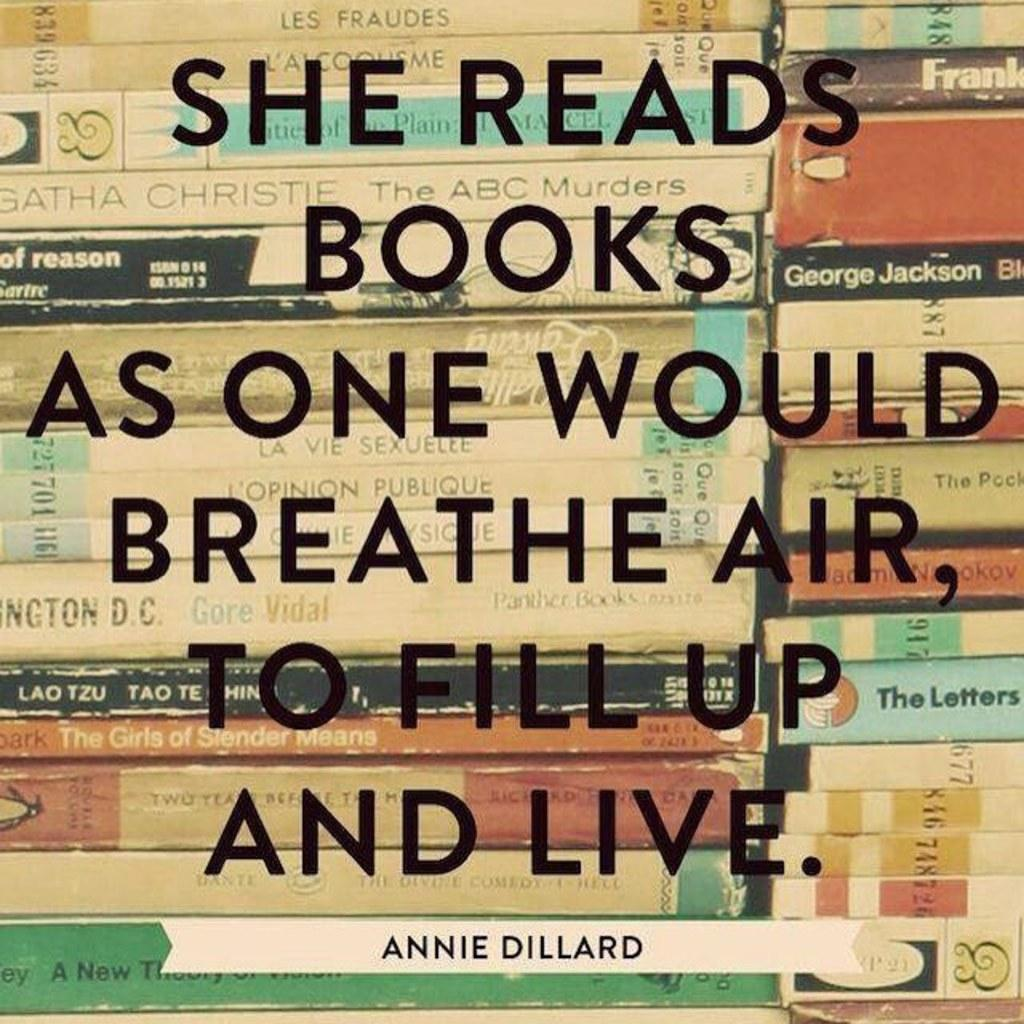<image>
Provide a brief description of the given image. Sign that says reads books as one would breathe air to fill up and live in front of books 